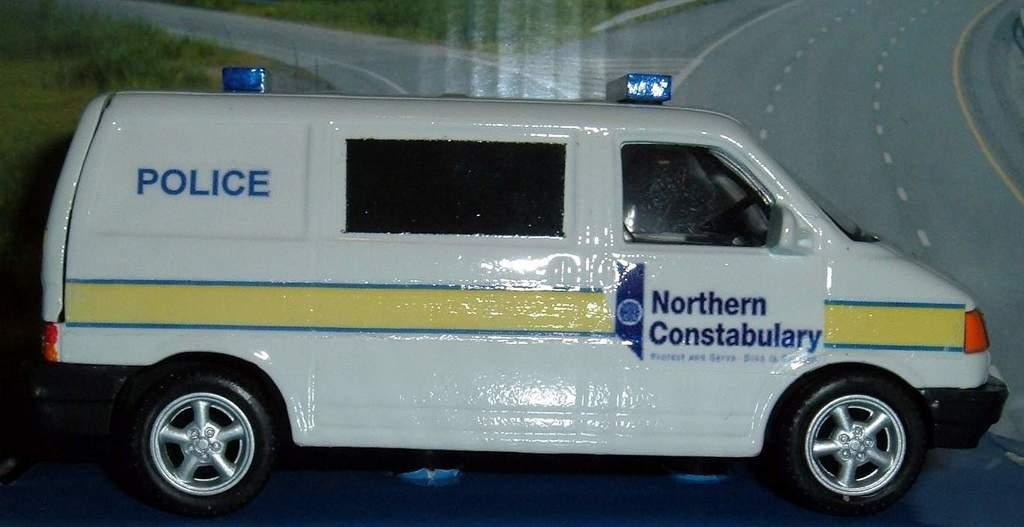<image>
Present a compact description of the photo's key features. White vehicle with blue words that say "Northern Constabulary". 